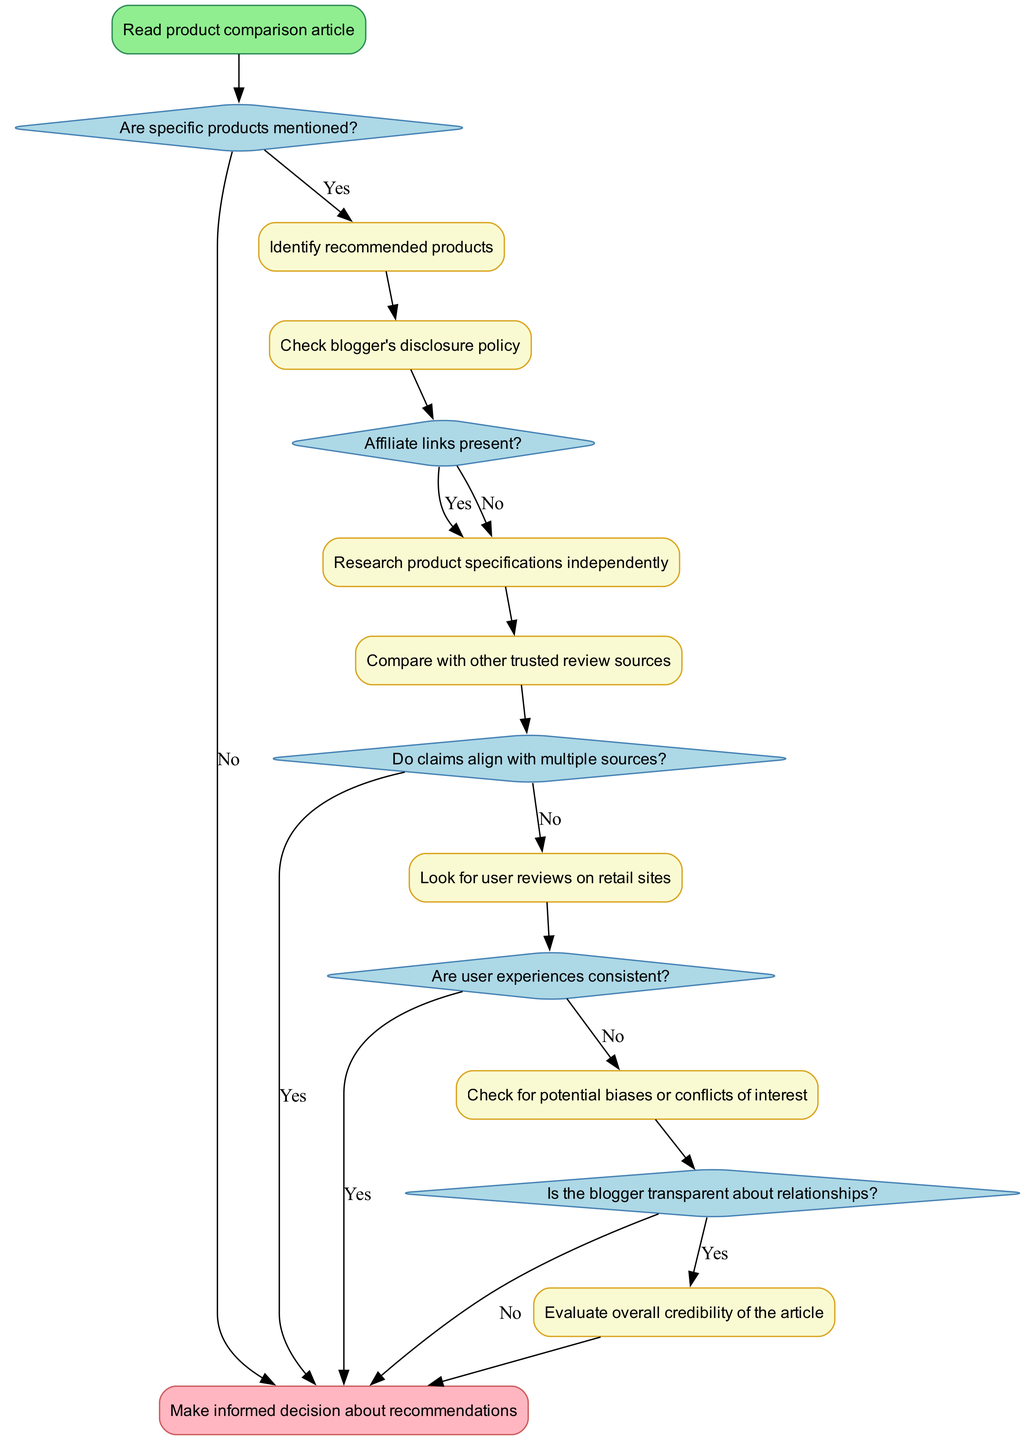What is the starting point of the diagram? The starting point of the diagram is labeled as "Read product comparison article," indicating where the process begins.
Answer: Read product comparison article How many decisions are present in the diagram? The diagram contains five decision nodes, each represented as diamonds indicating a choice or a question that leads to different paths in the flow.
Answer: 5 What action follows decision 2 if affiliate links are present? If affiliate links are present, the next action is "Research product specifications independently," which directs the flow to gather more information regarding the products.
Answer: Research product specifications independently What happens if user experiences are consistent? If user experiences are consistent, the flow reaches the end of the process, which indicates that no further action is needed on that branch. The diagram suggests that you would make an informed decision based on recommendations.
Answer: End What should be checked after identifying recommended products? After identifying recommended products, the next step is to "Check blogger's disclosure policy," ensuring transparency about any affiliate relationships that may influence the recommendations.
Answer: Check blogger's disclosure policy If claims align with multiple sources, what is the next step according to the flow? If claims align with multiple sources, the flow leads to "End," indicating that there is enough credibility established, and the decision can be made about the recommendations without further investigation.
Answer: End What action is taken if there are no consistent user experiences? If user experiences are not consistent, the next action is "Check for potential biases or conflicts of interest," which aims to uncover any underlying influences that may affect the objectivity of the reviews provided.
Answer: Check for potential biases or conflicts of interest How does the flow diagram conclude if the blogger is not transparent about relationships? If the blogger is not transparent about relationships, the flow leads to "End," suggesting that the lack of transparency is a critical factor that may impact the reliability of the recommendations made in the article.
Answer: End What is the final outcome of following the flowchart? The final outcome after following the steps in the flowchart is to "Make informed decision about recommendations," representing the goal of the fact-checking process.
Answer: Make informed decision about recommendations 